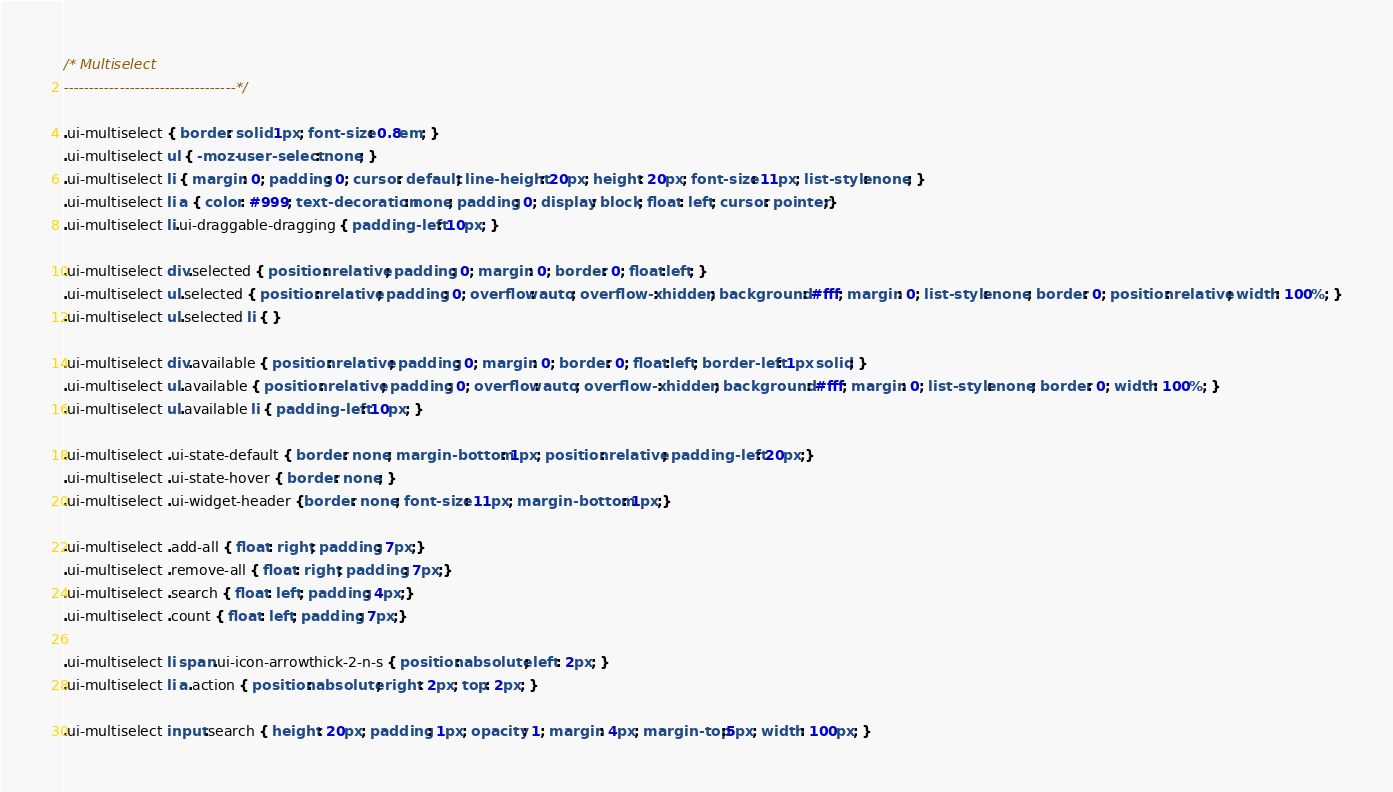<code> <loc_0><loc_0><loc_500><loc_500><_CSS_>/* Multiselect
----------------------------------*/

.ui-multiselect { border: solid 1px; font-size: 0.8em; }
.ui-multiselect ul { -moz-user-select: none; }
.ui-multiselect li { margin: 0; padding: 0; cursor: default; line-height: 20px; height: 20px; font-size: 11px; list-style: none; }
.ui-multiselect li a { color: #999; text-decoration: none; padding: 0; display: block; float: left; cursor: pointer;}
.ui-multiselect li.ui-draggable-dragging { padding-left: 10px; }

.ui-multiselect div.selected { position: relative; padding: 0; margin: 0; border: 0; float:left; }
.ui-multiselect ul.selected { position: relative; padding: 0; overflow: auto; overflow-x: hidden; background: #fff; margin: 0; list-style: none; border: 0; position: relative; width: 100%; }
.ui-multiselect ul.selected li { }

.ui-multiselect div.available { position: relative; padding: 0; margin: 0; border: 0; float:left; border-left: 1px solid; }
.ui-multiselect ul.available { position: relative; padding: 0; overflow: auto; overflow-x: hidden; background: #fff; margin: 0; list-style: none; border: 0; width: 100%; }
.ui-multiselect ul.available li { padding-left: 10px; }
 
.ui-multiselect .ui-state-default { border: none; margin-bottom: 1px; position: relative; padding-left: 20px;}
.ui-multiselect .ui-state-hover { border: none; }
.ui-multiselect .ui-widget-header {border: none; font-size: 11px; margin-bottom: 1px;}
 
.ui-multiselect .add-all { float: right; padding: 7px;}
.ui-multiselect .remove-all { float: right; padding: 7px;}
.ui-multiselect .search { float: left; padding: 4px;}
.ui-multiselect .count { float: left; padding: 7px;}

.ui-multiselect li span.ui-icon-arrowthick-2-n-s { position: absolute; left: 2px; }
.ui-multiselect li a.action { position: absolute; right: 2px; top: 2px; }
 
.ui-multiselect input.search { height: 20px; padding: 1px; opacity: 1; margin: 4px; margin-top:5px; width: 100px; }</code> 